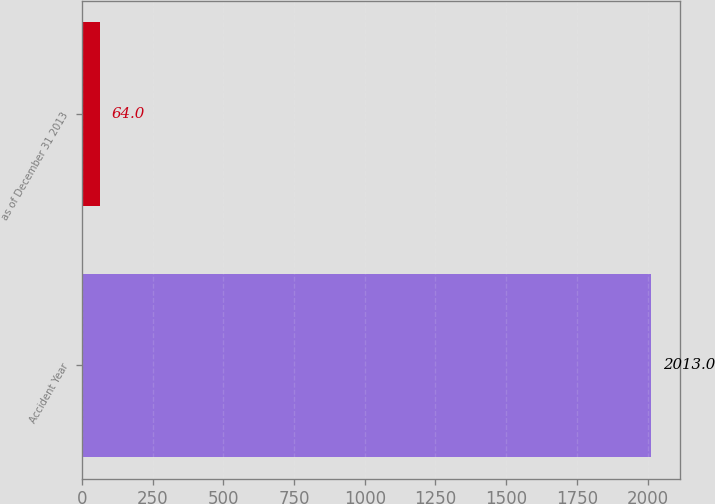Convert chart. <chart><loc_0><loc_0><loc_500><loc_500><bar_chart><fcel>Accident Year<fcel>as of December 31 2013<nl><fcel>2013<fcel>64<nl></chart> 